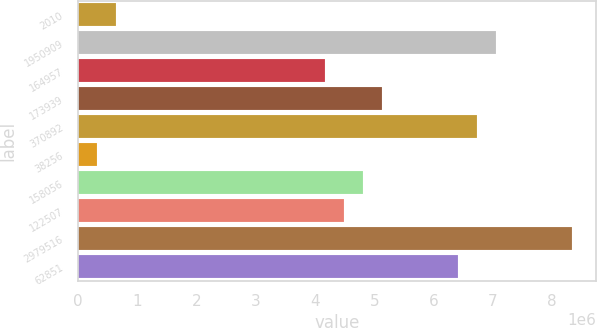Convert chart to OTSL. <chart><loc_0><loc_0><loc_500><loc_500><bar_chart><fcel>2010<fcel>1950909<fcel>164957<fcel>173939<fcel>370892<fcel>38256<fcel>158056<fcel>122507<fcel>2979516<fcel>62851<nl><fcel>640988<fcel>7.05085e+06<fcel>4.16641e+06<fcel>5.12789e+06<fcel>6.73036e+06<fcel>320495<fcel>4.8074e+06<fcel>4.4869e+06<fcel>8.33282e+06<fcel>6.40986e+06<nl></chart> 